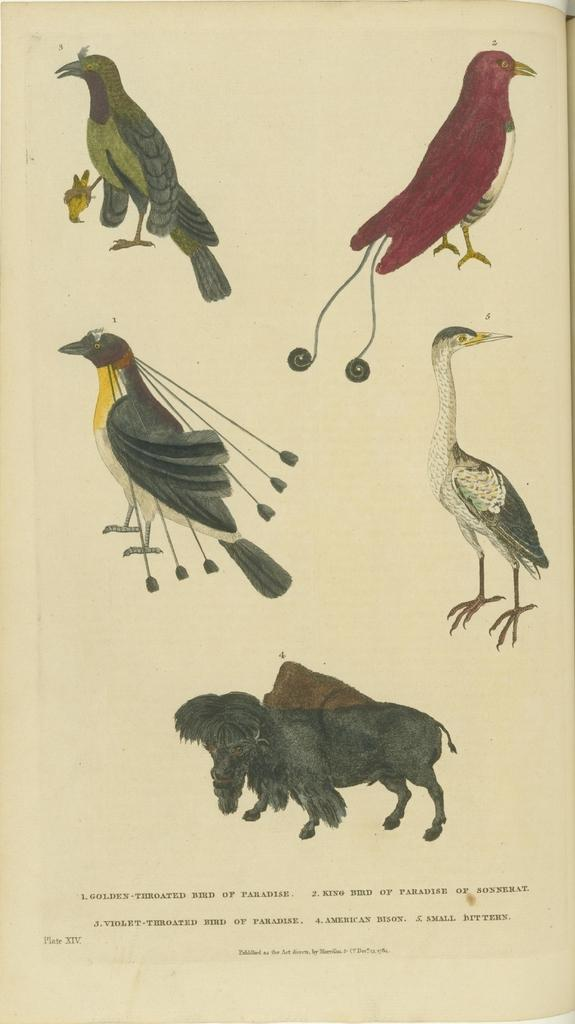What type of animals can be seen in the image? There are images of birds in the image. What else can be seen in the image besides the birds? There is an image of an animal in the image. What material are the images printed on? The images are printed on paper. What is located at the bottom of the image? There is text at the bottom of the image. What type of shirt is the bird wearing in the image? There are no birds wearing shirts in the image, as birds do not wear clothing. 